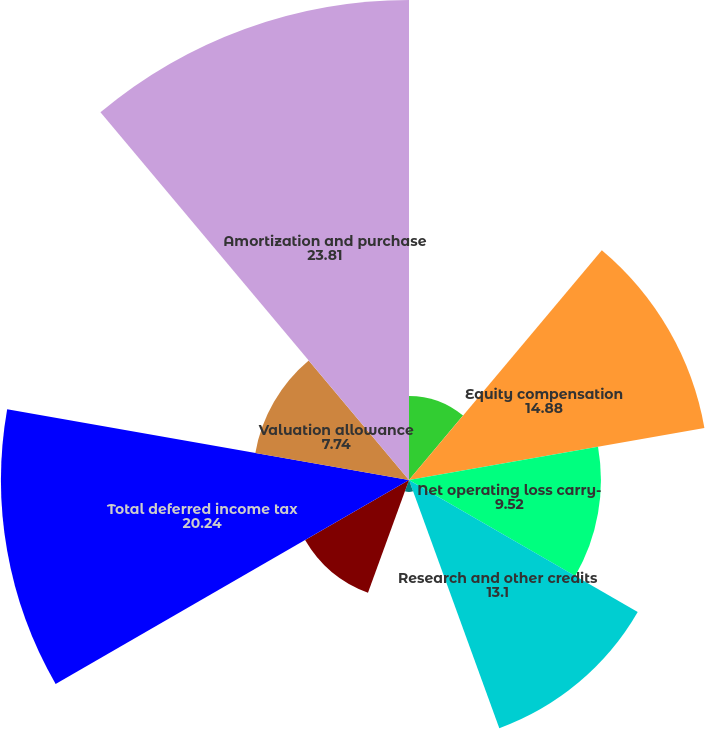<chart> <loc_0><loc_0><loc_500><loc_500><pie_chart><fcel>Inventory reserve<fcel>Equity compensation<fcel>Net operating loss carry-<fcel>Research and other credits<fcel>Employee benefits<fcel>Other deferred assets<fcel>Total deferred income tax<fcel>Valuation allowance<fcel>Amortization and purchase<nl><fcel>4.17%<fcel>14.88%<fcel>9.52%<fcel>13.1%<fcel>0.59%<fcel>5.95%<fcel>20.24%<fcel>7.74%<fcel>23.81%<nl></chart> 